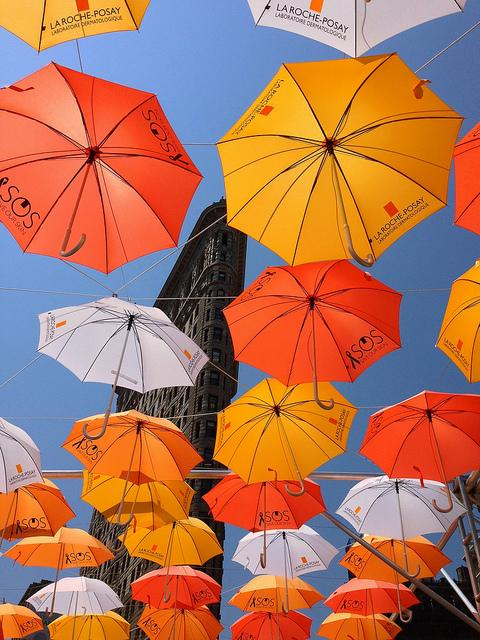What larger makeup group owns this company? sos 